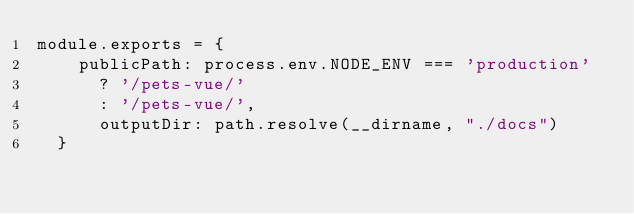<code> <loc_0><loc_0><loc_500><loc_500><_JavaScript_>module.exports = {
    publicPath: process.env.NODE_ENV === 'production'
      ? '/pets-vue/'
      : '/pets-vue/',
      outputDir: path.resolve(__dirname, "./docs")      
  }</code> 